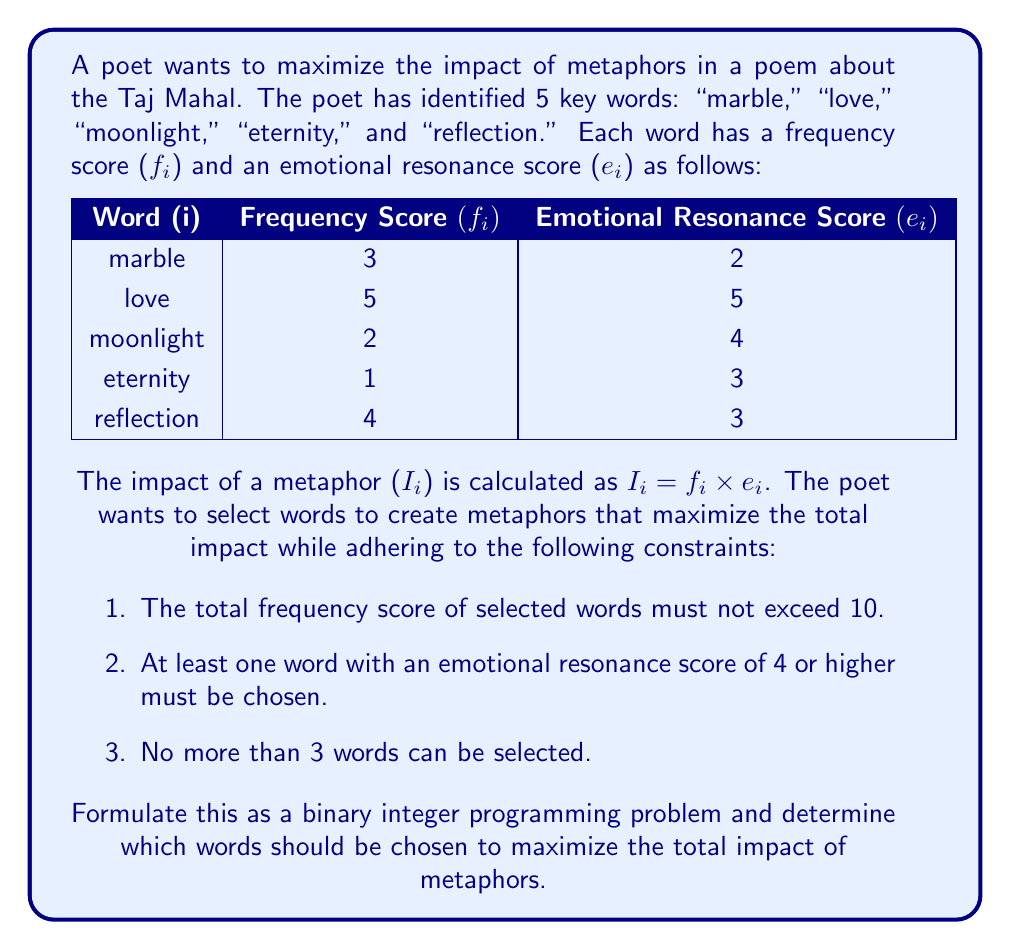Could you help me with this problem? To solve this problem, we need to formulate it as a binary integer programming problem. Let's define our decision variables:

$x_i = \begin{cases}
1 & \text{if word i is selected} \\
0 & \text{otherwise}
\end{cases}$

Our objective function is to maximize the total impact:

$$\text{Maximize } \sum_{i=1}^5 I_i x_i = \sum_{i=1}^5 f_i e_i x_i$$

Now, let's formulate the constraints:

1. Total frequency score constraint:
   $$\sum_{i=1}^5 f_i x_i \leq 10$$

2. At least one word with emotional resonance score of 4 or higher:
   $$x_2 + x_3 \geq 1$$
   (Since "love" and "moonlight" have emotional resonance scores of 4 or higher)

3. No more than 3 words can be selected:
   $$\sum_{i=1}^5 x_i \leq 3$$

4. Binary constraint:
   $$x_i \in \{0, 1\} \text{ for } i = 1, 2, 3, 4, 5$$

Now, let's solve this problem:

Objective function:
$$\text{Maximize } 3 \times 2 x_1 + 5 \times 5 x_2 + 2 \times 4 x_3 + 1 \times 3 x_4 + 4 \times 3 x_5$$
$$\text{Maximize } 6x_1 + 25x_2 + 8x_3 + 3x_4 + 12x_5$$

Constraints:
$$3x_1 + 5x_2 + 2x_3 + x_4 + 4x_5 \leq 10$$
$$x_2 + x_3 \geq 1$$
$$x_1 + x_2 + x_3 + x_4 + x_5 \leq 3$$
$$x_i \in \{0, 1\} \text{ for } i = 1, 2, 3, 4, 5$$

To solve this, we can use the branch and bound method or a solver. The optimal solution is:

$$x_1 = 0, x_2 = 1, x_3 = 1, x_4 = 0, x_5 = 0$$

This means we should select "love" and "moonlight".

The total impact is:
$$25 \times 1 + 8 \times 1 = 33$$

We can verify that this solution satisfies all constraints:
1. Total frequency: $5 + 2 = 7 \leq 10$
2. At least one word with high emotional resonance: Both selected words qualify
3. Number of words selected: 2 ≤ 3
Answer: The poet should choose the words "love" and "moonlight" to maximize the impact of metaphors. The maximum total impact achieved is 33. 